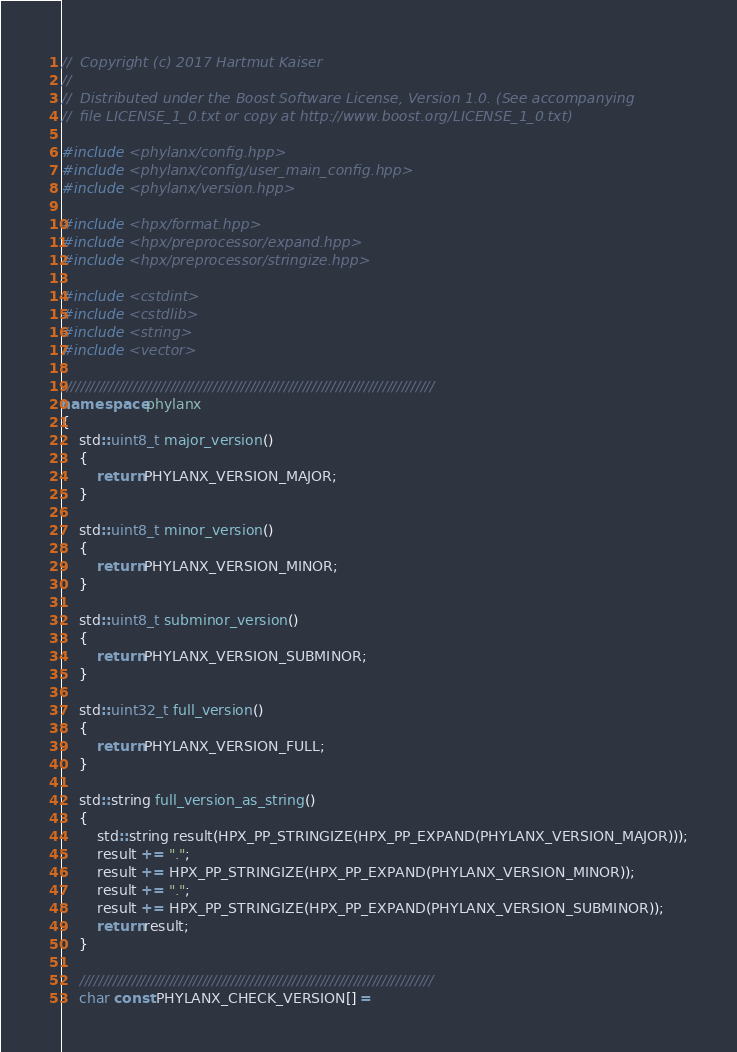Convert code to text. <code><loc_0><loc_0><loc_500><loc_500><_C++_>//  Copyright (c) 2017 Hartmut Kaiser
//
//  Distributed under the Boost Software License, Version 1.0. (See accompanying
//  file LICENSE_1_0.txt or copy at http://www.boost.org/LICENSE_1_0.txt)

#include <phylanx/config.hpp>
#include <phylanx/config/user_main_config.hpp>
#include <phylanx/version.hpp>

#include <hpx/format.hpp>
#include <hpx/preprocessor/expand.hpp>
#include <hpx/preprocessor/stringize.hpp>

#include <cstdint>
#include <cstdlib>
#include <string>
#include <vector>

///////////////////////////////////////////////////////////////////////////////
namespace phylanx
{
    std::uint8_t major_version()
    {
        return PHYLANX_VERSION_MAJOR;
    }

    std::uint8_t minor_version()
    {
        return PHYLANX_VERSION_MINOR;
    }

    std::uint8_t subminor_version()
    {
        return PHYLANX_VERSION_SUBMINOR;
    }

    std::uint32_t full_version()
    {
        return PHYLANX_VERSION_FULL;
    }

    std::string full_version_as_string()
    {
        std::string result(HPX_PP_STRINGIZE(HPX_PP_EXPAND(PHYLANX_VERSION_MAJOR)));
        result += ".";
        result += HPX_PP_STRINGIZE(HPX_PP_EXPAND(PHYLANX_VERSION_MINOR));
        result += ".";
        result += HPX_PP_STRINGIZE(HPX_PP_EXPAND(PHYLANX_VERSION_SUBMINOR));
        return result;
    }

    ///////////////////////////////////////////////////////////////////////////
    char const PHYLANX_CHECK_VERSION[] =</code> 